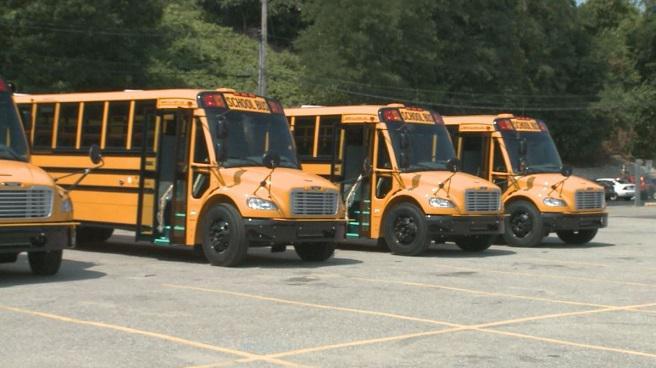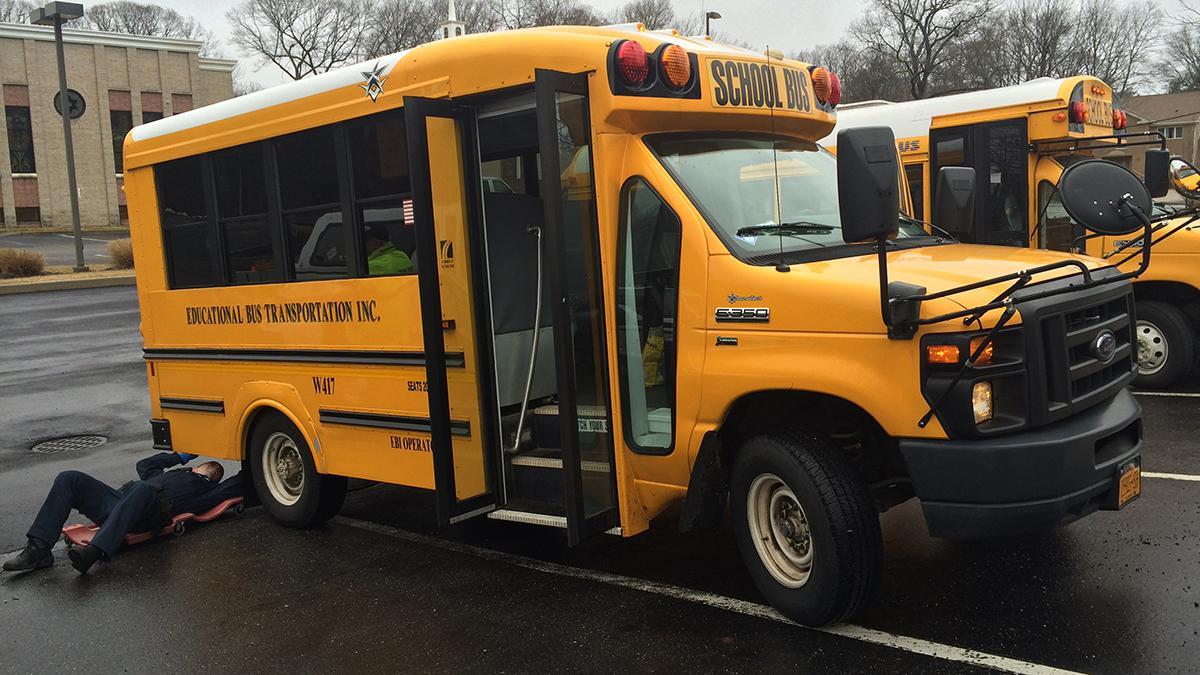The first image is the image on the left, the second image is the image on the right. Assess this claim about the two images: "In at least one image there is a short bus facing both right and forward.". Correct or not? Answer yes or no. Yes. The first image is the image on the left, the second image is the image on the right. Evaluate the accuracy of this statement regarding the images: "A bus has its passenger door open.". Is it true? Answer yes or no. Yes. 